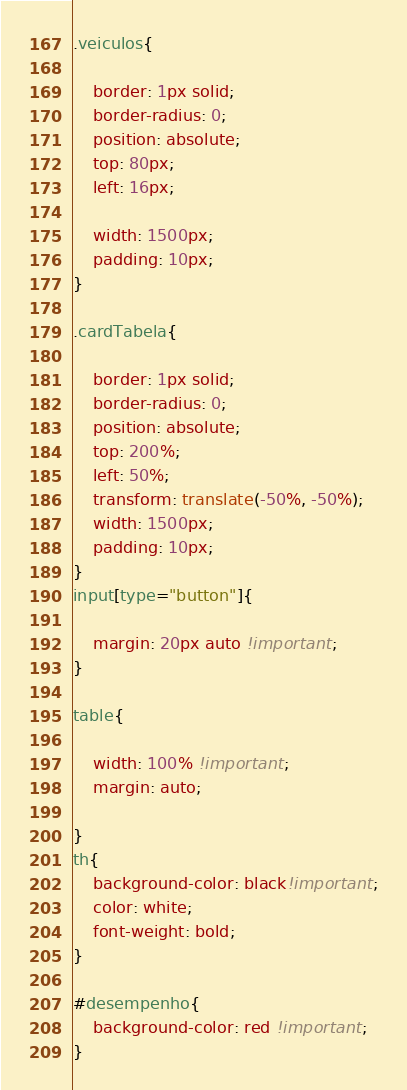Convert code to text. <code><loc_0><loc_0><loc_500><loc_500><_CSS_>.veiculos{

    border: 1px solid;
    border-radius: 0;
    position: absolute;
    top: 80px;
    left: 16px;
    
    width: 1500px;
    padding: 10px;
}

.cardTabela{

    border: 1px solid;
    border-radius: 0;
    position: absolute;
    top: 200%;
    left: 50%;
    transform: translate(-50%, -50%);
    width: 1500px;
    padding: 10px;
}
input[type="button"]{

    margin: 20px auto !important;
}

table{

    width: 100% !important;
    margin: auto;
  
}
th{
    background-color: black!important;
    color: white;
    font-weight: bold;
}

#desempenho{
    background-color: red !important;
}

</code> 